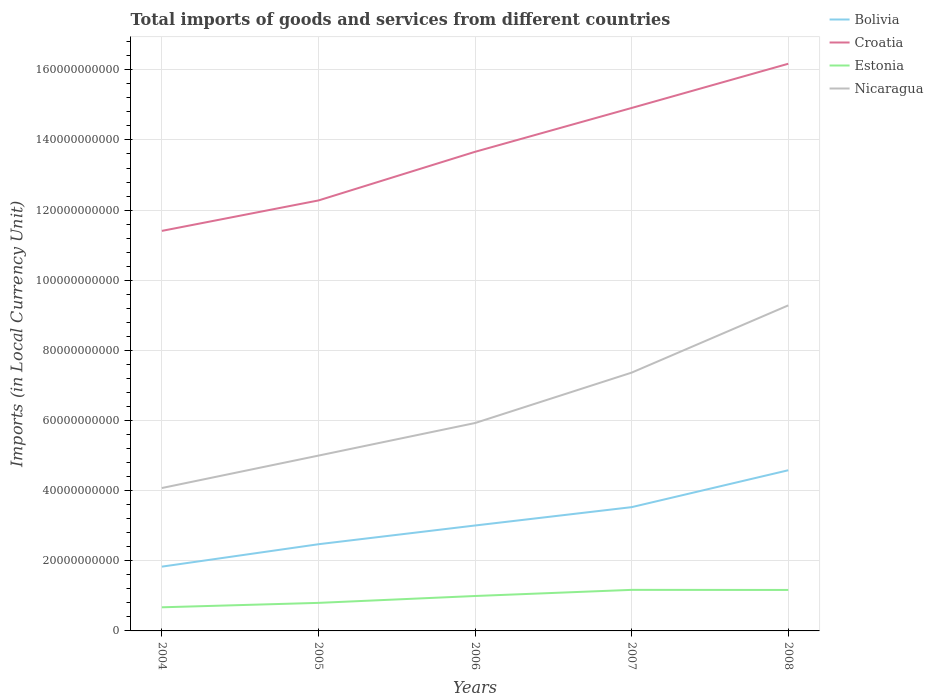How many different coloured lines are there?
Keep it short and to the point. 4. Does the line corresponding to Bolivia intersect with the line corresponding to Nicaragua?
Your answer should be compact. No. Is the number of lines equal to the number of legend labels?
Your response must be concise. Yes. Across all years, what is the maximum Amount of goods and services imports in Bolivia?
Give a very brief answer. 1.83e+1. What is the total Amount of goods and services imports in Nicaragua in the graph?
Your answer should be compact. -3.29e+1. What is the difference between the highest and the second highest Amount of goods and services imports in Estonia?
Your response must be concise. 4.97e+09. How many lines are there?
Your response must be concise. 4. What is the difference between two consecutive major ticks on the Y-axis?
Give a very brief answer. 2.00e+1. Are the values on the major ticks of Y-axis written in scientific E-notation?
Your answer should be compact. No. Does the graph contain grids?
Your answer should be compact. Yes. How are the legend labels stacked?
Provide a succinct answer. Vertical. What is the title of the graph?
Give a very brief answer. Total imports of goods and services from different countries. What is the label or title of the X-axis?
Make the answer very short. Years. What is the label or title of the Y-axis?
Provide a short and direct response. Imports (in Local Currency Unit). What is the Imports (in Local Currency Unit) of Bolivia in 2004?
Offer a very short reply. 1.83e+1. What is the Imports (in Local Currency Unit) in Croatia in 2004?
Ensure brevity in your answer.  1.14e+11. What is the Imports (in Local Currency Unit) of Estonia in 2004?
Offer a terse response. 6.74e+09. What is the Imports (in Local Currency Unit) of Nicaragua in 2004?
Provide a short and direct response. 4.07e+1. What is the Imports (in Local Currency Unit) in Bolivia in 2005?
Your response must be concise. 2.47e+1. What is the Imports (in Local Currency Unit) of Croatia in 2005?
Provide a succinct answer. 1.23e+11. What is the Imports (in Local Currency Unit) of Estonia in 2005?
Ensure brevity in your answer.  8.00e+09. What is the Imports (in Local Currency Unit) in Nicaragua in 2005?
Give a very brief answer. 5.00e+1. What is the Imports (in Local Currency Unit) of Bolivia in 2006?
Your answer should be very brief. 3.01e+1. What is the Imports (in Local Currency Unit) of Croatia in 2006?
Keep it short and to the point. 1.37e+11. What is the Imports (in Local Currency Unit) in Estonia in 2006?
Offer a very short reply. 9.96e+09. What is the Imports (in Local Currency Unit) in Nicaragua in 2006?
Provide a short and direct response. 5.93e+1. What is the Imports (in Local Currency Unit) of Bolivia in 2007?
Offer a very short reply. 3.53e+1. What is the Imports (in Local Currency Unit) in Croatia in 2007?
Ensure brevity in your answer.  1.49e+11. What is the Imports (in Local Currency Unit) in Estonia in 2007?
Make the answer very short. 1.17e+1. What is the Imports (in Local Currency Unit) in Nicaragua in 2007?
Your answer should be compact. 7.37e+1. What is the Imports (in Local Currency Unit) of Bolivia in 2008?
Give a very brief answer. 4.58e+1. What is the Imports (in Local Currency Unit) in Croatia in 2008?
Make the answer very short. 1.62e+11. What is the Imports (in Local Currency Unit) in Estonia in 2008?
Your answer should be very brief. 1.17e+1. What is the Imports (in Local Currency Unit) in Nicaragua in 2008?
Offer a very short reply. 9.28e+1. Across all years, what is the maximum Imports (in Local Currency Unit) in Bolivia?
Provide a short and direct response. 4.58e+1. Across all years, what is the maximum Imports (in Local Currency Unit) of Croatia?
Your answer should be compact. 1.62e+11. Across all years, what is the maximum Imports (in Local Currency Unit) in Estonia?
Your answer should be very brief. 1.17e+1. Across all years, what is the maximum Imports (in Local Currency Unit) in Nicaragua?
Offer a very short reply. 9.28e+1. Across all years, what is the minimum Imports (in Local Currency Unit) of Bolivia?
Ensure brevity in your answer.  1.83e+1. Across all years, what is the minimum Imports (in Local Currency Unit) in Croatia?
Give a very brief answer. 1.14e+11. Across all years, what is the minimum Imports (in Local Currency Unit) in Estonia?
Your answer should be compact. 6.74e+09. Across all years, what is the minimum Imports (in Local Currency Unit) in Nicaragua?
Offer a very short reply. 4.07e+1. What is the total Imports (in Local Currency Unit) in Bolivia in the graph?
Offer a terse response. 1.54e+11. What is the total Imports (in Local Currency Unit) in Croatia in the graph?
Keep it short and to the point. 6.84e+11. What is the total Imports (in Local Currency Unit) in Estonia in the graph?
Ensure brevity in your answer.  4.81e+1. What is the total Imports (in Local Currency Unit) in Nicaragua in the graph?
Your answer should be very brief. 3.17e+11. What is the difference between the Imports (in Local Currency Unit) of Bolivia in 2004 and that in 2005?
Your answer should be very brief. -6.39e+09. What is the difference between the Imports (in Local Currency Unit) in Croatia in 2004 and that in 2005?
Your response must be concise. -8.68e+09. What is the difference between the Imports (in Local Currency Unit) of Estonia in 2004 and that in 2005?
Provide a short and direct response. -1.26e+09. What is the difference between the Imports (in Local Currency Unit) in Nicaragua in 2004 and that in 2005?
Provide a short and direct response. -9.25e+09. What is the difference between the Imports (in Local Currency Unit) in Bolivia in 2004 and that in 2006?
Your response must be concise. -1.17e+1. What is the difference between the Imports (in Local Currency Unit) of Croatia in 2004 and that in 2006?
Your answer should be compact. -2.26e+1. What is the difference between the Imports (in Local Currency Unit) of Estonia in 2004 and that in 2006?
Provide a short and direct response. -3.22e+09. What is the difference between the Imports (in Local Currency Unit) of Nicaragua in 2004 and that in 2006?
Make the answer very short. -1.85e+1. What is the difference between the Imports (in Local Currency Unit) in Bolivia in 2004 and that in 2007?
Give a very brief answer. -1.70e+1. What is the difference between the Imports (in Local Currency Unit) in Croatia in 2004 and that in 2007?
Your answer should be compact. -3.51e+1. What is the difference between the Imports (in Local Currency Unit) of Estonia in 2004 and that in 2007?
Provide a succinct answer. -4.97e+09. What is the difference between the Imports (in Local Currency Unit) of Nicaragua in 2004 and that in 2007?
Give a very brief answer. -3.29e+1. What is the difference between the Imports (in Local Currency Unit) of Bolivia in 2004 and that in 2008?
Provide a short and direct response. -2.75e+1. What is the difference between the Imports (in Local Currency Unit) of Croatia in 2004 and that in 2008?
Provide a succinct answer. -4.77e+1. What is the difference between the Imports (in Local Currency Unit) in Estonia in 2004 and that in 2008?
Give a very brief answer. -4.95e+09. What is the difference between the Imports (in Local Currency Unit) in Nicaragua in 2004 and that in 2008?
Provide a short and direct response. -5.21e+1. What is the difference between the Imports (in Local Currency Unit) in Bolivia in 2005 and that in 2006?
Your answer should be very brief. -5.34e+09. What is the difference between the Imports (in Local Currency Unit) of Croatia in 2005 and that in 2006?
Provide a short and direct response. -1.39e+1. What is the difference between the Imports (in Local Currency Unit) of Estonia in 2005 and that in 2006?
Keep it short and to the point. -1.96e+09. What is the difference between the Imports (in Local Currency Unit) in Nicaragua in 2005 and that in 2006?
Provide a succinct answer. -9.29e+09. What is the difference between the Imports (in Local Currency Unit) in Bolivia in 2005 and that in 2007?
Provide a succinct answer. -1.06e+1. What is the difference between the Imports (in Local Currency Unit) in Croatia in 2005 and that in 2007?
Ensure brevity in your answer.  -2.64e+1. What is the difference between the Imports (in Local Currency Unit) in Estonia in 2005 and that in 2007?
Provide a short and direct response. -3.71e+09. What is the difference between the Imports (in Local Currency Unit) in Nicaragua in 2005 and that in 2007?
Offer a terse response. -2.37e+1. What is the difference between the Imports (in Local Currency Unit) in Bolivia in 2005 and that in 2008?
Offer a terse response. -2.11e+1. What is the difference between the Imports (in Local Currency Unit) in Croatia in 2005 and that in 2008?
Offer a terse response. -3.90e+1. What is the difference between the Imports (in Local Currency Unit) of Estonia in 2005 and that in 2008?
Provide a short and direct response. -3.68e+09. What is the difference between the Imports (in Local Currency Unit) in Nicaragua in 2005 and that in 2008?
Your answer should be very brief. -4.28e+1. What is the difference between the Imports (in Local Currency Unit) of Bolivia in 2006 and that in 2007?
Offer a terse response. -5.24e+09. What is the difference between the Imports (in Local Currency Unit) of Croatia in 2006 and that in 2007?
Offer a very short reply. -1.25e+1. What is the difference between the Imports (in Local Currency Unit) in Estonia in 2006 and that in 2007?
Give a very brief answer. -1.75e+09. What is the difference between the Imports (in Local Currency Unit) of Nicaragua in 2006 and that in 2007?
Your answer should be compact. -1.44e+1. What is the difference between the Imports (in Local Currency Unit) of Bolivia in 2006 and that in 2008?
Give a very brief answer. -1.58e+1. What is the difference between the Imports (in Local Currency Unit) in Croatia in 2006 and that in 2008?
Your answer should be very brief. -2.51e+1. What is the difference between the Imports (in Local Currency Unit) of Estonia in 2006 and that in 2008?
Your answer should be compact. -1.73e+09. What is the difference between the Imports (in Local Currency Unit) in Nicaragua in 2006 and that in 2008?
Your answer should be very brief. -3.35e+1. What is the difference between the Imports (in Local Currency Unit) of Bolivia in 2007 and that in 2008?
Your answer should be very brief. -1.05e+1. What is the difference between the Imports (in Local Currency Unit) of Croatia in 2007 and that in 2008?
Offer a very short reply. -1.26e+1. What is the difference between the Imports (in Local Currency Unit) of Estonia in 2007 and that in 2008?
Keep it short and to the point. 2.69e+07. What is the difference between the Imports (in Local Currency Unit) of Nicaragua in 2007 and that in 2008?
Make the answer very short. -1.92e+1. What is the difference between the Imports (in Local Currency Unit) of Bolivia in 2004 and the Imports (in Local Currency Unit) of Croatia in 2005?
Provide a succinct answer. -1.04e+11. What is the difference between the Imports (in Local Currency Unit) of Bolivia in 2004 and the Imports (in Local Currency Unit) of Estonia in 2005?
Ensure brevity in your answer.  1.03e+1. What is the difference between the Imports (in Local Currency Unit) in Bolivia in 2004 and the Imports (in Local Currency Unit) in Nicaragua in 2005?
Offer a terse response. -3.17e+1. What is the difference between the Imports (in Local Currency Unit) in Croatia in 2004 and the Imports (in Local Currency Unit) in Estonia in 2005?
Provide a succinct answer. 1.06e+11. What is the difference between the Imports (in Local Currency Unit) in Croatia in 2004 and the Imports (in Local Currency Unit) in Nicaragua in 2005?
Keep it short and to the point. 6.41e+1. What is the difference between the Imports (in Local Currency Unit) of Estonia in 2004 and the Imports (in Local Currency Unit) of Nicaragua in 2005?
Make the answer very short. -4.33e+1. What is the difference between the Imports (in Local Currency Unit) of Bolivia in 2004 and the Imports (in Local Currency Unit) of Croatia in 2006?
Ensure brevity in your answer.  -1.18e+11. What is the difference between the Imports (in Local Currency Unit) of Bolivia in 2004 and the Imports (in Local Currency Unit) of Estonia in 2006?
Keep it short and to the point. 8.37e+09. What is the difference between the Imports (in Local Currency Unit) in Bolivia in 2004 and the Imports (in Local Currency Unit) in Nicaragua in 2006?
Make the answer very short. -4.10e+1. What is the difference between the Imports (in Local Currency Unit) in Croatia in 2004 and the Imports (in Local Currency Unit) in Estonia in 2006?
Give a very brief answer. 1.04e+11. What is the difference between the Imports (in Local Currency Unit) of Croatia in 2004 and the Imports (in Local Currency Unit) of Nicaragua in 2006?
Make the answer very short. 5.48e+1. What is the difference between the Imports (in Local Currency Unit) of Estonia in 2004 and the Imports (in Local Currency Unit) of Nicaragua in 2006?
Keep it short and to the point. -5.25e+1. What is the difference between the Imports (in Local Currency Unit) of Bolivia in 2004 and the Imports (in Local Currency Unit) of Croatia in 2007?
Offer a terse response. -1.31e+11. What is the difference between the Imports (in Local Currency Unit) in Bolivia in 2004 and the Imports (in Local Currency Unit) in Estonia in 2007?
Your response must be concise. 6.62e+09. What is the difference between the Imports (in Local Currency Unit) of Bolivia in 2004 and the Imports (in Local Currency Unit) of Nicaragua in 2007?
Your response must be concise. -5.53e+1. What is the difference between the Imports (in Local Currency Unit) of Croatia in 2004 and the Imports (in Local Currency Unit) of Estonia in 2007?
Your answer should be very brief. 1.02e+11. What is the difference between the Imports (in Local Currency Unit) in Croatia in 2004 and the Imports (in Local Currency Unit) in Nicaragua in 2007?
Offer a very short reply. 4.04e+1. What is the difference between the Imports (in Local Currency Unit) in Estonia in 2004 and the Imports (in Local Currency Unit) in Nicaragua in 2007?
Your answer should be compact. -6.69e+1. What is the difference between the Imports (in Local Currency Unit) of Bolivia in 2004 and the Imports (in Local Currency Unit) of Croatia in 2008?
Ensure brevity in your answer.  -1.43e+11. What is the difference between the Imports (in Local Currency Unit) in Bolivia in 2004 and the Imports (in Local Currency Unit) in Estonia in 2008?
Provide a succinct answer. 6.65e+09. What is the difference between the Imports (in Local Currency Unit) in Bolivia in 2004 and the Imports (in Local Currency Unit) in Nicaragua in 2008?
Ensure brevity in your answer.  -7.45e+1. What is the difference between the Imports (in Local Currency Unit) of Croatia in 2004 and the Imports (in Local Currency Unit) of Estonia in 2008?
Keep it short and to the point. 1.02e+11. What is the difference between the Imports (in Local Currency Unit) in Croatia in 2004 and the Imports (in Local Currency Unit) in Nicaragua in 2008?
Your answer should be compact. 2.12e+1. What is the difference between the Imports (in Local Currency Unit) of Estonia in 2004 and the Imports (in Local Currency Unit) of Nicaragua in 2008?
Offer a terse response. -8.61e+1. What is the difference between the Imports (in Local Currency Unit) in Bolivia in 2005 and the Imports (in Local Currency Unit) in Croatia in 2006?
Provide a succinct answer. -1.12e+11. What is the difference between the Imports (in Local Currency Unit) in Bolivia in 2005 and the Imports (in Local Currency Unit) in Estonia in 2006?
Make the answer very short. 1.48e+1. What is the difference between the Imports (in Local Currency Unit) in Bolivia in 2005 and the Imports (in Local Currency Unit) in Nicaragua in 2006?
Ensure brevity in your answer.  -3.46e+1. What is the difference between the Imports (in Local Currency Unit) of Croatia in 2005 and the Imports (in Local Currency Unit) of Estonia in 2006?
Make the answer very short. 1.13e+11. What is the difference between the Imports (in Local Currency Unit) of Croatia in 2005 and the Imports (in Local Currency Unit) of Nicaragua in 2006?
Give a very brief answer. 6.35e+1. What is the difference between the Imports (in Local Currency Unit) in Estonia in 2005 and the Imports (in Local Currency Unit) in Nicaragua in 2006?
Offer a very short reply. -5.13e+1. What is the difference between the Imports (in Local Currency Unit) of Bolivia in 2005 and the Imports (in Local Currency Unit) of Croatia in 2007?
Provide a short and direct response. -1.24e+11. What is the difference between the Imports (in Local Currency Unit) of Bolivia in 2005 and the Imports (in Local Currency Unit) of Estonia in 2007?
Provide a succinct answer. 1.30e+1. What is the difference between the Imports (in Local Currency Unit) of Bolivia in 2005 and the Imports (in Local Currency Unit) of Nicaragua in 2007?
Keep it short and to the point. -4.89e+1. What is the difference between the Imports (in Local Currency Unit) of Croatia in 2005 and the Imports (in Local Currency Unit) of Estonia in 2007?
Offer a very short reply. 1.11e+11. What is the difference between the Imports (in Local Currency Unit) of Croatia in 2005 and the Imports (in Local Currency Unit) of Nicaragua in 2007?
Give a very brief answer. 4.91e+1. What is the difference between the Imports (in Local Currency Unit) of Estonia in 2005 and the Imports (in Local Currency Unit) of Nicaragua in 2007?
Give a very brief answer. -6.57e+1. What is the difference between the Imports (in Local Currency Unit) in Bolivia in 2005 and the Imports (in Local Currency Unit) in Croatia in 2008?
Offer a very short reply. -1.37e+11. What is the difference between the Imports (in Local Currency Unit) in Bolivia in 2005 and the Imports (in Local Currency Unit) in Estonia in 2008?
Keep it short and to the point. 1.30e+1. What is the difference between the Imports (in Local Currency Unit) of Bolivia in 2005 and the Imports (in Local Currency Unit) of Nicaragua in 2008?
Your answer should be compact. -6.81e+1. What is the difference between the Imports (in Local Currency Unit) of Croatia in 2005 and the Imports (in Local Currency Unit) of Estonia in 2008?
Offer a very short reply. 1.11e+11. What is the difference between the Imports (in Local Currency Unit) of Croatia in 2005 and the Imports (in Local Currency Unit) of Nicaragua in 2008?
Make the answer very short. 2.99e+1. What is the difference between the Imports (in Local Currency Unit) in Estonia in 2005 and the Imports (in Local Currency Unit) in Nicaragua in 2008?
Provide a short and direct response. -8.48e+1. What is the difference between the Imports (in Local Currency Unit) in Bolivia in 2006 and the Imports (in Local Currency Unit) in Croatia in 2007?
Give a very brief answer. -1.19e+11. What is the difference between the Imports (in Local Currency Unit) in Bolivia in 2006 and the Imports (in Local Currency Unit) in Estonia in 2007?
Make the answer very short. 1.84e+1. What is the difference between the Imports (in Local Currency Unit) in Bolivia in 2006 and the Imports (in Local Currency Unit) in Nicaragua in 2007?
Provide a succinct answer. -4.36e+1. What is the difference between the Imports (in Local Currency Unit) in Croatia in 2006 and the Imports (in Local Currency Unit) in Estonia in 2007?
Make the answer very short. 1.25e+11. What is the difference between the Imports (in Local Currency Unit) in Croatia in 2006 and the Imports (in Local Currency Unit) in Nicaragua in 2007?
Your response must be concise. 6.30e+1. What is the difference between the Imports (in Local Currency Unit) of Estonia in 2006 and the Imports (in Local Currency Unit) of Nicaragua in 2007?
Your response must be concise. -6.37e+1. What is the difference between the Imports (in Local Currency Unit) in Bolivia in 2006 and the Imports (in Local Currency Unit) in Croatia in 2008?
Offer a terse response. -1.32e+11. What is the difference between the Imports (in Local Currency Unit) of Bolivia in 2006 and the Imports (in Local Currency Unit) of Estonia in 2008?
Ensure brevity in your answer.  1.84e+1. What is the difference between the Imports (in Local Currency Unit) of Bolivia in 2006 and the Imports (in Local Currency Unit) of Nicaragua in 2008?
Your answer should be compact. -6.28e+1. What is the difference between the Imports (in Local Currency Unit) of Croatia in 2006 and the Imports (in Local Currency Unit) of Estonia in 2008?
Your answer should be very brief. 1.25e+11. What is the difference between the Imports (in Local Currency Unit) in Croatia in 2006 and the Imports (in Local Currency Unit) in Nicaragua in 2008?
Give a very brief answer. 4.38e+1. What is the difference between the Imports (in Local Currency Unit) in Estonia in 2006 and the Imports (in Local Currency Unit) in Nicaragua in 2008?
Offer a very short reply. -8.29e+1. What is the difference between the Imports (in Local Currency Unit) of Bolivia in 2007 and the Imports (in Local Currency Unit) of Croatia in 2008?
Keep it short and to the point. -1.26e+11. What is the difference between the Imports (in Local Currency Unit) in Bolivia in 2007 and the Imports (in Local Currency Unit) in Estonia in 2008?
Ensure brevity in your answer.  2.36e+1. What is the difference between the Imports (in Local Currency Unit) in Bolivia in 2007 and the Imports (in Local Currency Unit) in Nicaragua in 2008?
Provide a short and direct response. -5.75e+1. What is the difference between the Imports (in Local Currency Unit) of Croatia in 2007 and the Imports (in Local Currency Unit) of Estonia in 2008?
Make the answer very short. 1.37e+11. What is the difference between the Imports (in Local Currency Unit) in Croatia in 2007 and the Imports (in Local Currency Unit) in Nicaragua in 2008?
Your response must be concise. 5.63e+1. What is the difference between the Imports (in Local Currency Unit) of Estonia in 2007 and the Imports (in Local Currency Unit) of Nicaragua in 2008?
Keep it short and to the point. -8.11e+1. What is the average Imports (in Local Currency Unit) of Bolivia per year?
Your answer should be very brief. 3.08e+1. What is the average Imports (in Local Currency Unit) of Croatia per year?
Provide a succinct answer. 1.37e+11. What is the average Imports (in Local Currency Unit) of Estonia per year?
Give a very brief answer. 9.62e+09. What is the average Imports (in Local Currency Unit) of Nicaragua per year?
Offer a very short reply. 6.33e+1. In the year 2004, what is the difference between the Imports (in Local Currency Unit) of Bolivia and Imports (in Local Currency Unit) of Croatia?
Provide a succinct answer. -9.57e+1. In the year 2004, what is the difference between the Imports (in Local Currency Unit) of Bolivia and Imports (in Local Currency Unit) of Estonia?
Ensure brevity in your answer.  1.16e+1. In the year 2004, what is the difference between the Imports (in Local Currency Unit) in Bolivia and Imports (in Local Currency Unit) in Nicaragua?
Give a very brief answer. -2.24e+1. In the year 2004, what is the difference between the Imports (in Local Currency Unit) in Croatia and Imports (in Local Currency Unit) in Estonia?
Ensure brevity in your answer.  1.07e+11. In the year 2004, what is the difference between the Imports (in Local Currency Unit) in Croatia and Imports (in Local Currency Unit) in Nicaragua?
Offer a terse response. 7.33e+1. In the year 2004, what is the difference between the Imports (in Local Currency Unit) of Estonia and Imports (in Local Currency Unit) of Nicaragua?
Offer a terse response. -3.40e+1. In the year 2005, what is the difference between the Imports (in Local Currency Unit) of Bolivia and Imports (in Local Currency Unit) of Croatia?
Ensure brevity in your answer.  -9.80e+1. In the year 2005, what is the difference between the Imports (in Local Currency Unit) of Bolivia and Imports (in Local Currency Unit) of Estonia?
Your answer should be compact. 1.67e+1. In the year 2005, what is the difference between the Imports (in Local Currency Unit) in Bolivia and Imports (in Local Currency Unit) in Nicaragua?
Provide a short and direct response. -2.53e+1. In the year 2005, what is the difference between the Imports (in Local Currency Unit) of Croatia and Imports (in Local Currency Unit) of Estonia?
Your answer should be very brief. 1.15e+11. In the year 2005, what is the difference between the Imports (in Local Currency Unit) of Croatia and Imports (in Local Currency Unit) of Nicaragua?
Your answer should be compact. 7.28e+1. In the year 2005, what is the difference between the Imports (in Local Currency Unit) of Estonia and Imports (in Local Currency Unit) of Nicaragua?
Your answer should be very brief. -4.20e+1. In the year 2006, what is the difference between the Imports (in Local Currency Unit) in Bolivia and Imports (in Local Currency Unit) in Croatia?
Ensure brevity in your answer.  -1.07e+11. In the year 2006, what is the difference between the Imports (in Local Currency Unit) of Bolivia and Imports (in Local Currency Unit) of Estonia?
Offer a very short reply. 2.01e+1. In the year 2006, what is the difference between the Imports (in Local Currency Unit) of Bolivia and Imports (in Local Currency Unit) of Nicaragua?
Your answer should be very brief. -2.92e+1. In the year 2006, what is the difference between the Imports (in Local Currency Unit) in Croatia and Imports (in Local Currency Unit) in Estonia?
Provide a short and direct response. 1.27e+11. In the year 2006, what is the difference between the Imports (in Local Currency Unit) in Croatia and Imports (in Local Currency Unit) in Nicaragua?
Give a very brief answer. 7.73e+1. In the year 2006, what is the difference between the Imports (in Local Currency Unit) of Estonia and Imports (in Local Currency Unit) of Nicaragua?
Offer a terse response. -4.93e+1. In the year 2007, what is the difference between the Imports (in Local Currency Unit) in Bolivia and Imports (in Local Currency Unit) in Croatia?
Make the answer very short. -1.14e+11. In the year 2007, what is the difference between the Imports (in Local Currency Unit) in Bolivia and Imports (in Local Currency Unit) in Estonia?
Offer a terse response. 2.36e+1. In the year 2007, what is the difference between the Imports (in Local Currency Unit) of Bolivia and Imports (in Local Currency Unit) of Nicaragua?
Keep it short and to the point. -3.84e+1. In the year 2007, what is the difference between the Imports (in Local Currency Unit) in Croatia and Imports (in Local Currency Unit) in Estonia?
Your response must be concise. 1.37e+11. In the year 2007, what is the difference between the Imports (in Local Currency Unit) in Croatia and Imports (in Local Currency Unit) in Nicaragua?
Provide a short and direct response. 7.55e+1. In the year 2007, what is the difference between the Imports (in Local Currency Unit) in Estonia and Imports (in Local Currency Unit) in Nicaragua?
Provide a succinct answer. -6.19e+1. In the year 2008, what is the difference between the Imports (in Local Currency Unit) of Bolivia and Imports (in Local Currency Unit) of Croatia?
Ensure brevity in your answer.  -1.16e+11. In the year 2008, what is the difference between the Imports (in Local Currency Unit) in Bolivia and Imports (in Local Currency Unit) in Estonia?
Your answer should be compact. 3.41e+1. In the year 2008, what is the difference between the Imports (in Local Currency Unit) in Bolivia and Imports (in Local Currency Unit) in Nicaragua?
Keep it short and to the point. -4.70e+1. In the year 2008, what is the difference between the Imports (in Local Currency Unit) in Croatia and Imports (in Local Currency Unit) in Estonia?
Keep it short and to the point. 1.50e+11. In the year 2008, what is the difference between the Imports (in Local Currency Unit) of Croatia and Imports (in Local Currency Unit) of Nicaragua?
Your answer should be compact. 6.89e+1. In the year 2008, what is the difference between the Imports (in Local Currency Unit) in Estonia and Imports (in Local Currency Unit) in Nicaragua?
Your answer should be compact. -8.11e+1. What is the ratio of the Imports (in Local Currency Unit) of Bolivia in 2004 to that in 2005?
Make the answer very short. 0.74. What is the ratio of the Imports (in Local Currency Unit) in Croatia in 2004 to that in 2005?
Provide a succinct answer. 0.93. What is the ratio of the Imports (in Local Currency Unit) in Estonia in 2004 to that in 2005?
Your answer should be compact. 0.84. What is the ratio of the Imports (in Local Currency Unit) of Nicaragua in 2004 to that in 2005?
Keep it short and to the point. 0.81. What is the ratio of the Imports (in Local Currency Unit) of Bolivia in 2004 to that in 2006?
Ensure brevity in your answer.  0.61. What is the ratio of the Imports (in Local Currency Unit) of Croatia in 2004 to that in 2006?
Give a very brief answer. 0.83. What is the ratio of the Imports (in Local Currency Unit) of Estonia in 2004 to that in 2006?
Your response must be concise. 0.68. What is the ratio of the Imports (in Local Currency Unit) in Nicaragua in 2004 to that in 2006?
Provide a short and direct response. 0.69. What is the ratio of the Imports (in Local Currency Unit) of Bolivia in 2004 to that in 2007?
Provide a succinct answer. 0.52. What is the ratio of the Imports (in Local Currency Unit) in Croatia in 2004 to that in 2007?
Make the answer very short. 0.76. What is the ratio of the Imports (in Local Currency Unit) in Estonia in 2004 to that in 2007?
Ensure brevity in your answer.  0.58. What is the ratio of the Imports (in Local Currency Unit) of Nicaragua in 2004 to that in 2007?
Provide a short and direct response. 0.55. What is the ratio of the Imports (in Local Currency Unit) of Bolivia in 2004 to that in 2008?
Make the answer very short. 0.4. What is the ratio of the Imports (in Local Currency Unit) in Croatia in 2004 to that in 2008?
Provide a succinct answer. 0.71. What is the ratio of the Imports (in Local Currency Unit) in Estonia in 2004 to that in 2008?
Your answer should be compact. 0.58. What is the ratio of the Imports (in Local Currency Unit) in Nicaragua in 2004 to that in 2008?
Give a very brief answer. 0.44. What is the ratio of the Imports (in Local Currency Unit) in Bolivia in 2005 to that in 2006?
Your answer should be compact. 0.82. What is the ratio of the Imports (in Local Currency Unit) in Croatia in 2005 to that in 2006?
Make the answer very short. 0.9. What is the ratio of the Imports (in Local Currency Unit) of Estonia in 2005 to that in 2006?
Provide a succinct answer. 0.8. What is the ratio of the Imports (in Local Currency Unit) of Nicaragua in 2005 to that in 2006?
Make the answer very short. 0.84. What is the ratio of the Imports (in Local Currency Unit) of Bolivia in 2005 to that in 2007?
Offer a very short reply. 0.7. What is the ratio of the Imports (in Local Currency Unit) of Croatia in 2005 to that in 2007?
Provide a succinct answer. 0.82. What is the ratio of the Imports (in Local Currency Unit) of Estonia in 2005 to that in 2007?
Offer a terse response. 0.68. What is the ratio of the Imports (in Local Currency Unit) in Nicaragua in 2005 to that in 2007?
Ensure brevity in your answer.  0.68. What is the ratio of the Imports (in Local Currency Unit) in Bolivia in 2005 to that in 2008?
Ensure brevity in your answer.  0.54. What is the ratio of the Imports (in Local Currency Unit) of Croatia in 2005 to that in 2008?
Provide a succinct answer. 0.76. What is the ratio of the Imports (in Local Currency Unit) of Estonia in 2005 to that in 2008?
Provide a short and direct response. 0.68. What is the ratio of the Imports (in Local Currency Unit) in Nicaragua in 2005 to that in 2008?
Provide a succinct answer. 0.54. What is the ratio of the Imports (in Local Currency Unit) in Bolivia in 2006 to that in 2007?
Provide a short and direct response. 0.85. What is the ratio of the Imports (in Local Currency Unit) in Croatia in 2006 to that in 2007?
Offer a very short reply. 0.92. What is the ratio of the Imports (in Local Currency Unit) of Estonia in 2006 to that in 2007?
Ensure brevity in your answer.  0.85. What is the ratio of the Imports (in Local Currency Unit) in Nicaragua in 2006 to that in 2007?
Give a very brief answer. 0.8. What is the ratio of the Imports (in Local Currency Unit) in Bolivia in 2006 to that in 2008?
Make the answer very short. 0.66. What is the ratio of the Imports (in Local Currency Unit) in Croatia in 2006 to that in 2008?
Make the answer very short. 0.84. What is the ratio of the Imports (in Local Currency Unit) of Estonia in 2006 to that in 2008?
Your answer should be compact. 0.85. What is the ratio of the Imports (in Local Currency Unit) of Nicaragua in 2006 to that in 2008?
Keep it short and to the point. 0.64. What is the ratio of the Imports (in Local Currency Unit) of Bolivia in 2007 to that in 2008?
Provide a succinct answer. 0.77. What is the ratio of the Imports (in Local Currency Unit) of Croatia in 2007 to that in 2008?
Your answer should be very brief. 0.92. What is the ratio of the Imports (in Local Currency Unit) of Nicaragua in 2007 to that in 2008?
Keep it short and to the point. 0.79. What is the difference between the highest and the second highest Imports (in Local Currency Unit) of Bolivia?
Your answer should be very brief. 1.05e+1. What is the difference between the highest and the second highest Imports (in Local Currency Unit) of Croatia?
Ensure brevity in your answer.  1.26e+1. What is the difference between the highest and the second highest Imports (in Local Currency Unit) of Estonia?
Give a very brief answer. 2.69e+07. What is the difference between the highest and the second highest Imports (in Local Currency Unit) of Nicaragua?
Provide a succinct answer. 1.92e+1. What is the difference between the highest and the lowest Imports (in Local Currency Unit) in Bolivia?
Ensure brevity in your answer.  2.75e+1. What is the difference between the highest and the lowest Imports (in Local Currency Unit) in Croatia?
Ensure brevity in your answer.  4.77e+1. What is the difference between the highest and the lowest Imports (in Local Currency Unit) in Estonia?
Your answer should be very brief. 4.97e+09. What is the difference between the highest and the lowest Imports (in Local Currency Unit) of Nicaragua?
Your answer should be compact. 5.21e+1. 